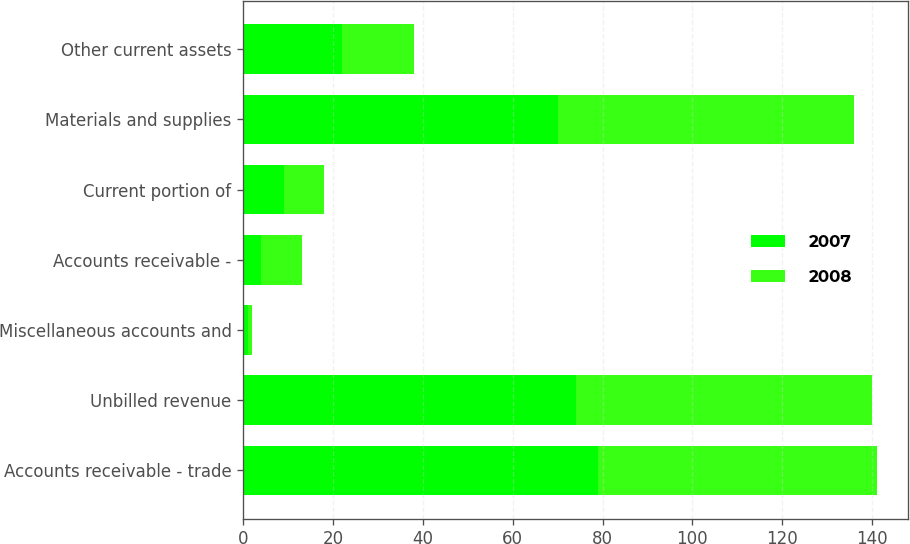<chart> <loc_0><loc_0><loc_500><loc_500><stacked_bar_chart><ecel><fcel>Accounts receivable - trade<fcel>Unbilled revenue<fcel>Miscellaneous accounts and<fcel>Accounts receivable -<fcel>Current portion of<fcel>Materials and supplies<fcel>Other current assets<nl><fcel>2007<fcel>79<fcel>74<fcel>1<fcel>4<fcel>9<fcel>70<fcel>22<nl><fcel>2008<fcel>62<fcel>66<fcel>1<fcel>9<fcel>9<fcel>66<fcel>16<nl></chart> 